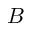Convert formula to latex. <formula><loc_0><loc_0><loc_500><loc_500>B</formula> 